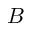Convert formula to latex. <formula><loc_0><loc_0><loc_500><loc_500>B</formula> 